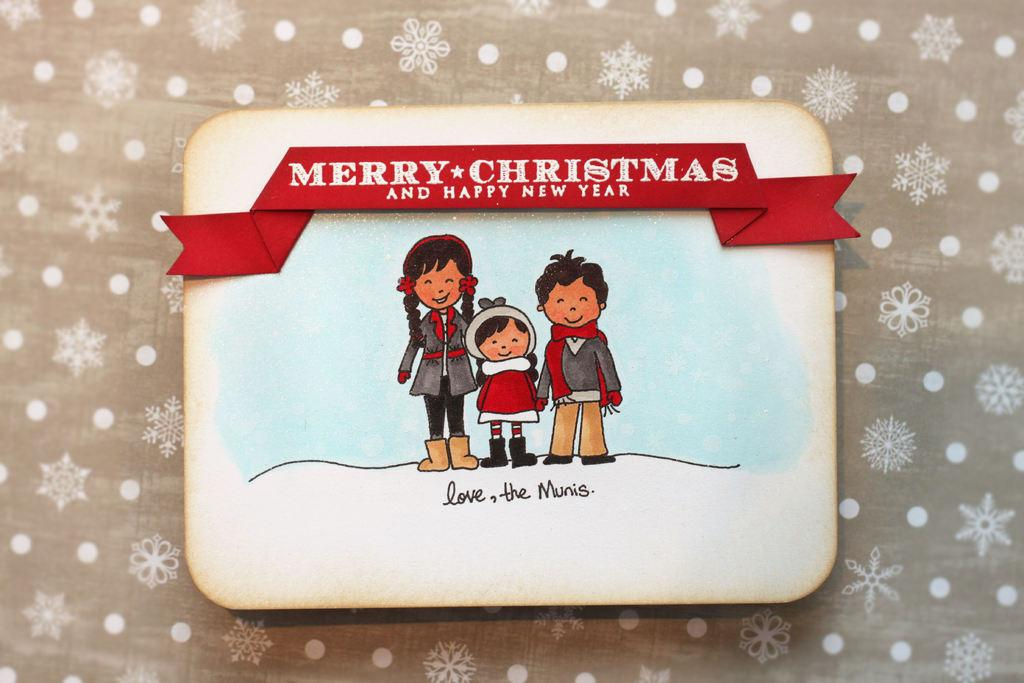What is the main object in the image? There is a card in the image. What can be found on the card? The card has text and images on it. Is there anything attached to the card? Yes, there is a ribbon on the card. What is written on the ribbon? The ribbon has text on it. Where is the card and ribbon placed? The card and ribbon are on a cloth. What type of copper material is used to create the spiders on the cloth? There are no spiders or copper material present in the image. 